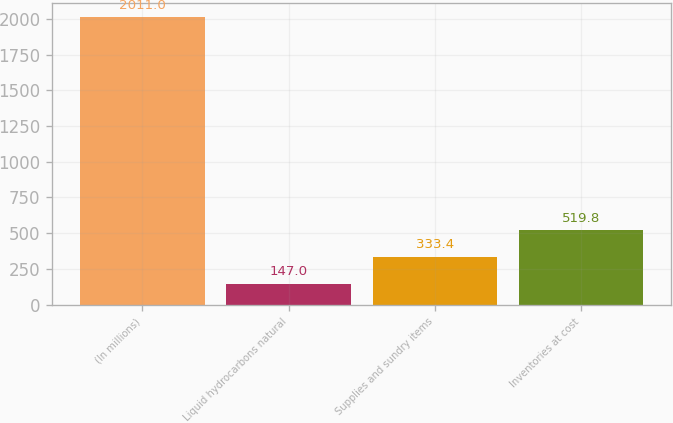Convert chart to OTSL. <chart><loc_0><loc_0><loc_500><loc_500><bar_chart><fcel>(In millions)<fcel>Liquid hydrocarbons natural<fcel>Supplies and sundry items<fcel>Inventories at cost<nl><fcel>2011<fcel>147<fcel>333.4<fcel>519.8<nl></chart> 